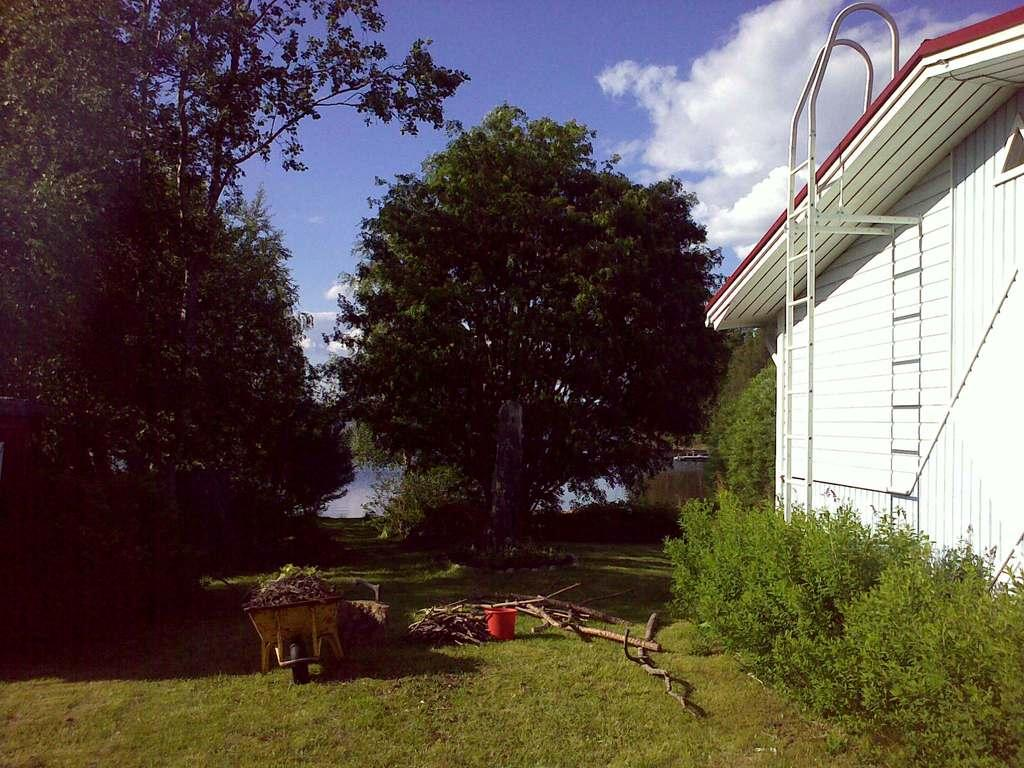What can be seen in the image that is used for holding or carrying items? There is a bucket in the image, which can be used for holding or carrying items. What type of material is used for the objects in the image? The objects in the image are made of wood. Where are the carts located in the image? The carts are on the grass in the image. What is the structure on the right side of the image? There is a ladder to a house on the right side of the image. How would you describe the sky in the image? The sky is blue and cloudy in the image. What shape is the sponge in the image? There is no sponge present in the image. What type of home is shown in the image? The image does not show a home; it shows a ladder to a house. How many squares are visible in the image? There are no squares visible in the image. 